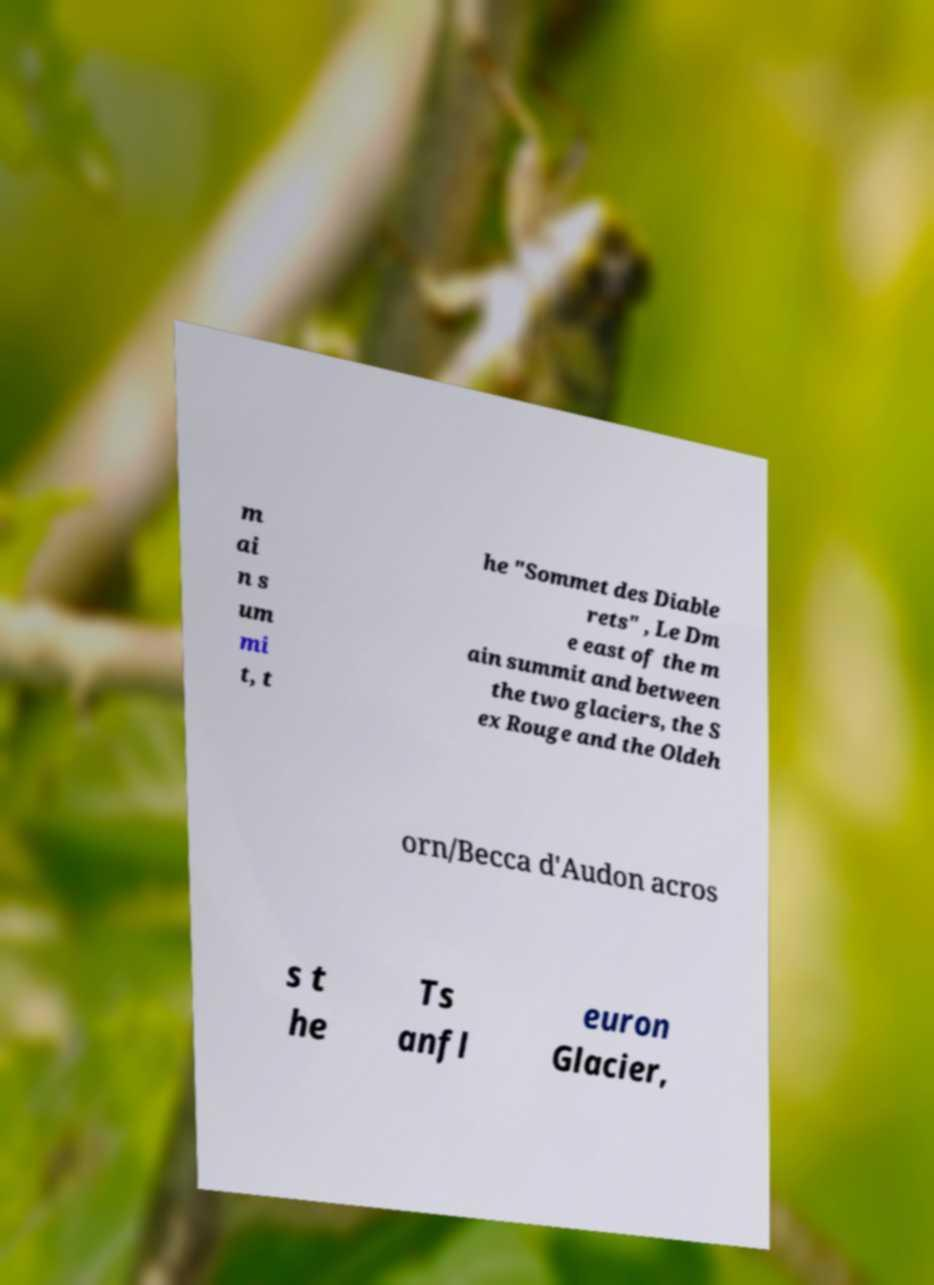Please identify and transcribe the text found in this image. m ai n s um mi t, t he "Sommet des Diable rets" , Le Dm e east of the m ain summit and between the two glaciers, the S ex Rouge and the Oldeh orn/Becca d'Audon acros s t he Ts anfl euron Glacier, 